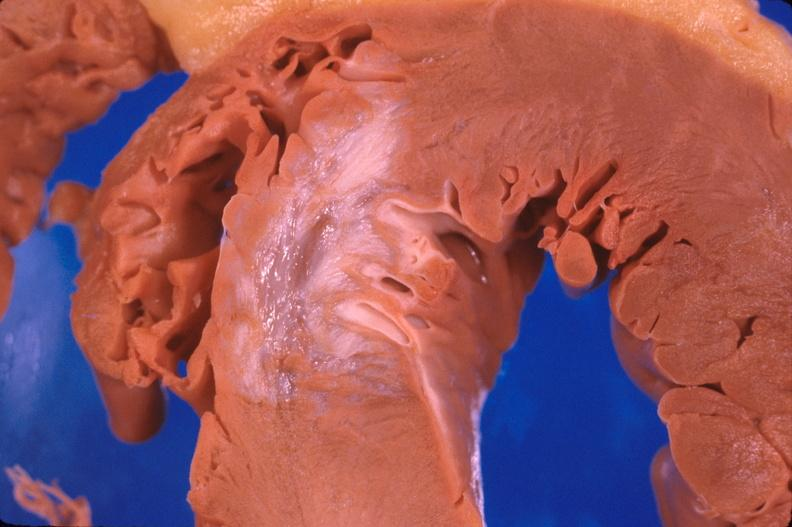s intraductal papillomatosis with apocrine metaplasia present?
Answer the question using a single word or phrase. No 